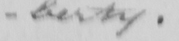Transcribe the text shown in this historical manuscript line. -berty . ] 